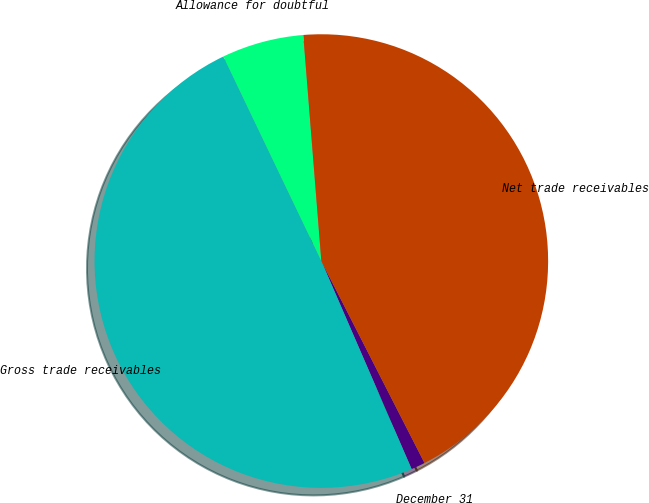Convert chart. <chart><loc_0><loc_0><loc_500><loc_500><pie_chart><fcel>December 31<fcel>Gross trade receivables<fcel>Allowance for doubtful<fcel>Net trade receivables<nl><fcel>1.0%<fcel>49.41%<fcel>5.84%<fcel>43.75%<nl></chart> 